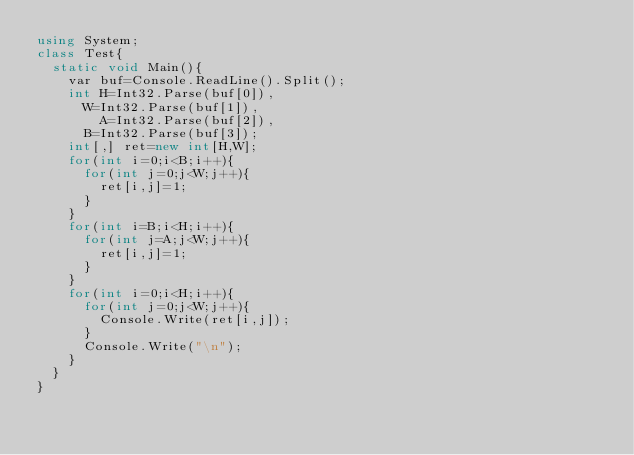<code> <loc_0><loc_0><loc_500><loc_500><_C#_>using System;
class Test{
  static void Main(){
    var buf=Console.ReadLine().Split();
    int H=Int32.Parse(buf[0]),
    	W=Int32.Parse(buf[1]),
        A=Int32.Parse(buf[2]),
    	B=Int32.Parse(buf[3]);
    int[,] ret=new int[H,W];
    for(int i=0;i<B;i++){
      for(int j=0;j<W;j++){
        ret[i,j]=1;
      }
    }
    for(int i=B;i<H;i++){
      for(int j=A;j<W;j++){
        ret[i,j]=1;
      }
    }
    for(int i=0;i<H;i++){
      for(int j=0;j<W;j++){
        Console.Write(ret[i,j]);
      }
      Console.Write("\n");
    }
  }
}</code> 